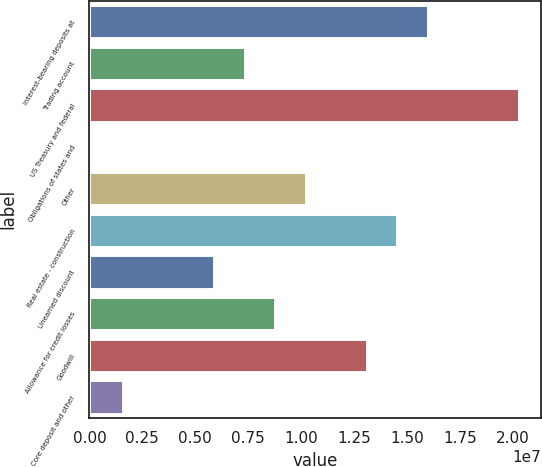Convert chart to OTSL. <chart><loc_0><loc_0><loc_500><loc_500><bar_chart><fcel>Interest-bearing deposits at<fcel>Trading account<fcel>US Treasury and federal<fcel>Obligations of states and<fcel>Other<fcel>Real estate - construction<fcel>Unearned discount<fcel>Allowance for credit losses<fcel>Goodwill<fcel>Core deposit and other<nl><fcel>1.59818e+07<fcel>7.33235e+06<fcel>2.03065e+07<fcel>124459<fcel>1.02155e+07<fcel>1.45402e+07<fcel>5.89077e+06<fcel>8.77393e+06<fcel>1.30987e+07<fcel>1.56604e+06<nl></chart> 